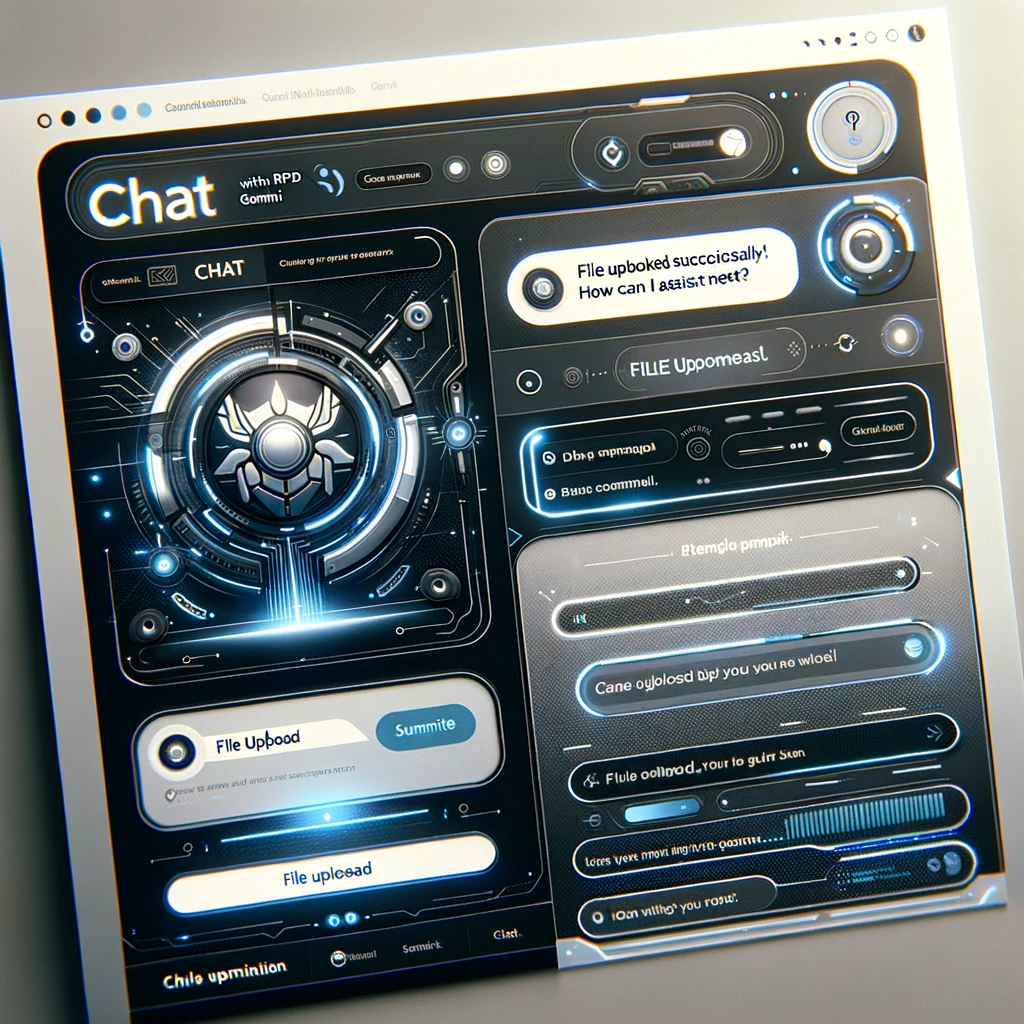explain about the images The image appears to be a graphical user interface (GUI) for a messaging or chat application. The main features I can observe are:

1. The title of the application is "Chat with RPD Gommi".

2. The central part of the interface displays a chat conversation, with a message saying "File uploaded successfully! How can I assist next?"

3. There are various interactive elements such as buttons, sliders, and input fields that allow the user to perform actions like uploading files, sending messages, and navigating the application.

4. The overall design has a futuristic, science-fiction inspired aesthetic, with glowing elements, mechanical-looking interfaces, and abstract UI elements.

5. There are no identifiable human faces or individuals visible in the image. The focus is entirely on the graphical user interface and the interactive chat functionality. 